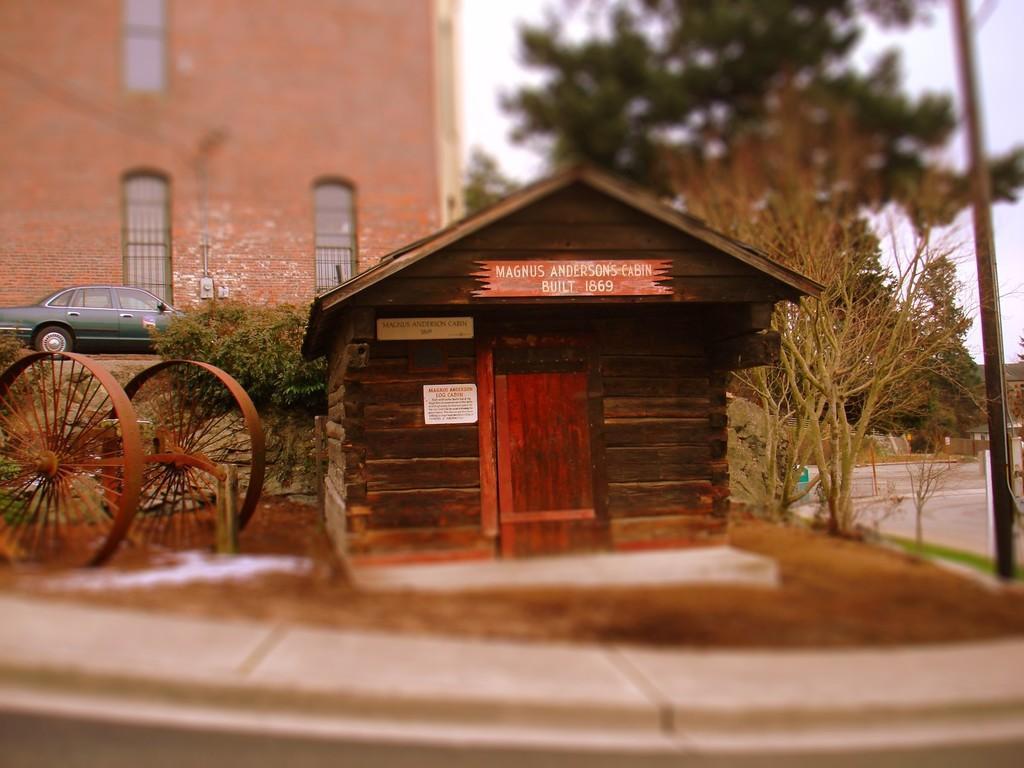In one or two sentences, can you explain what this image depicts? In this image we can see a wooden house with boards, there are metal wheels beside the house and on the right side there is an iron pole and in the background there is a car in front of the building and there are few trees and the sky. 